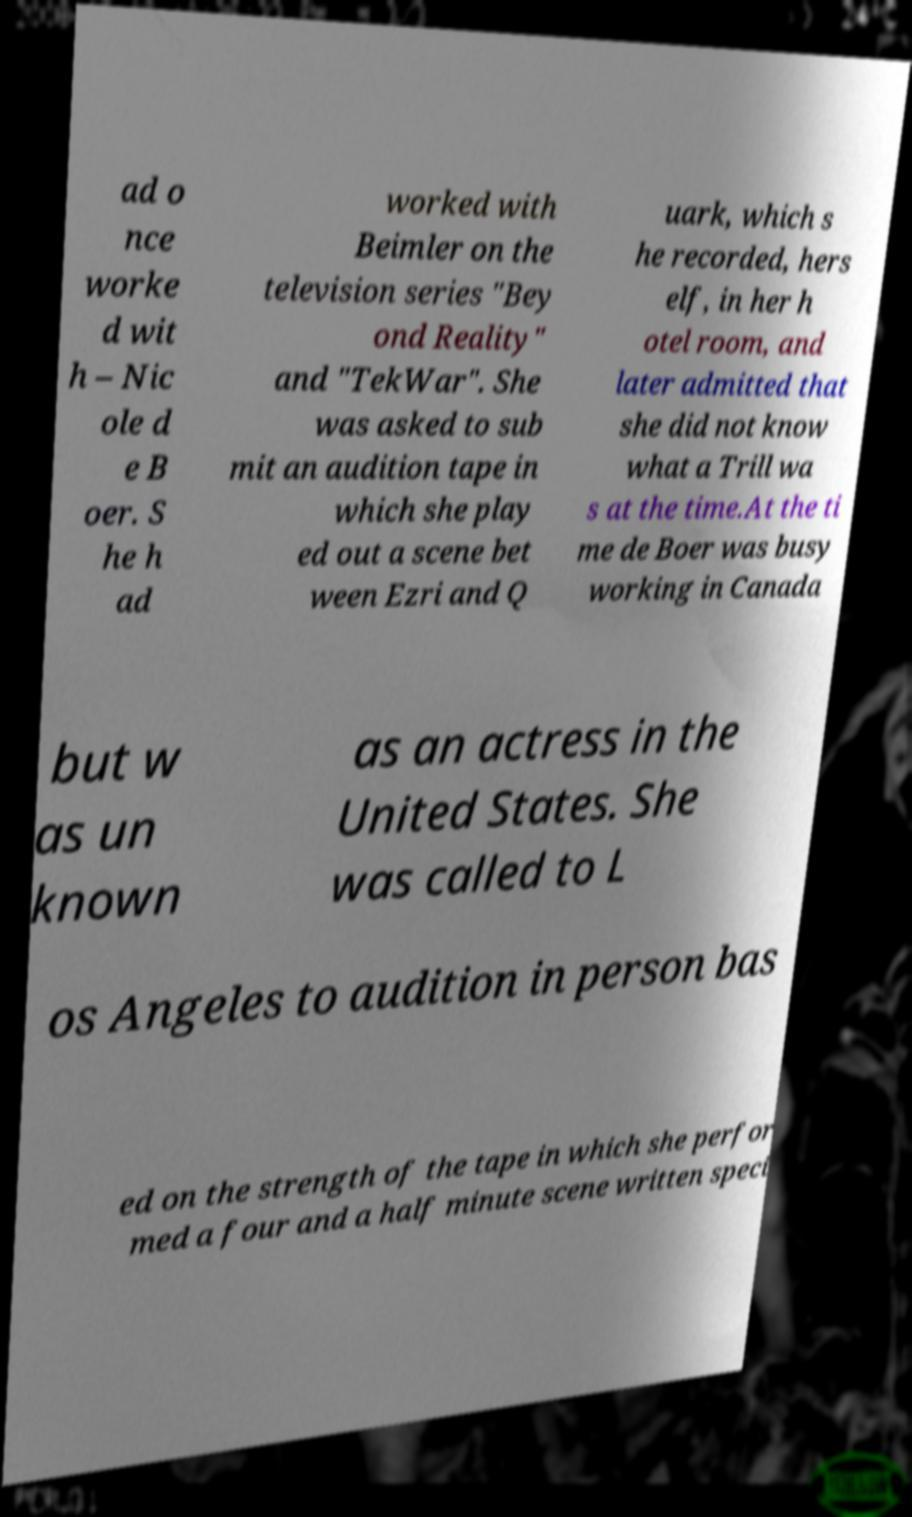Could you extract and type out the text from this image? ad o nce worke d wit h – Nic ole d e B oer. S he h ad worked with Beimler on the television series "Bey ond Reality" and "TekWar". She was asked to sub mit an audition tape in which she play ed out a scene bet ween Ezri and Q uark, which s he recorded, hers elf, in her h otel room, and later admitted that she did not know what a Trill wa s at the time.At the ti me de Boer was busy working in Canada but w as un known as an actress in the United States. She was called to L os Angeles to audition in person bas ed on the strength of the tape in which she perfor med a four and a half minute scene written speci 